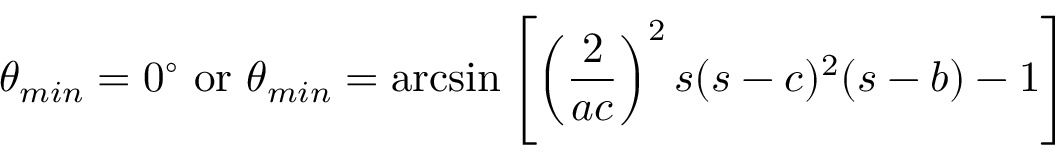Convert formula to latex. <formula><loc_0><loc_0><loc_500><loc_500>\theta _ { \min } = 0 ^ { \circ } \, o r \, \theta _ { \min } = \arcsin \left [ \left ( \frac { 2 } { a c } \right ) ^ { 2 } s ( s - c ) ^ { 2 } ( s - b ) - 1 \right ]</formula> 